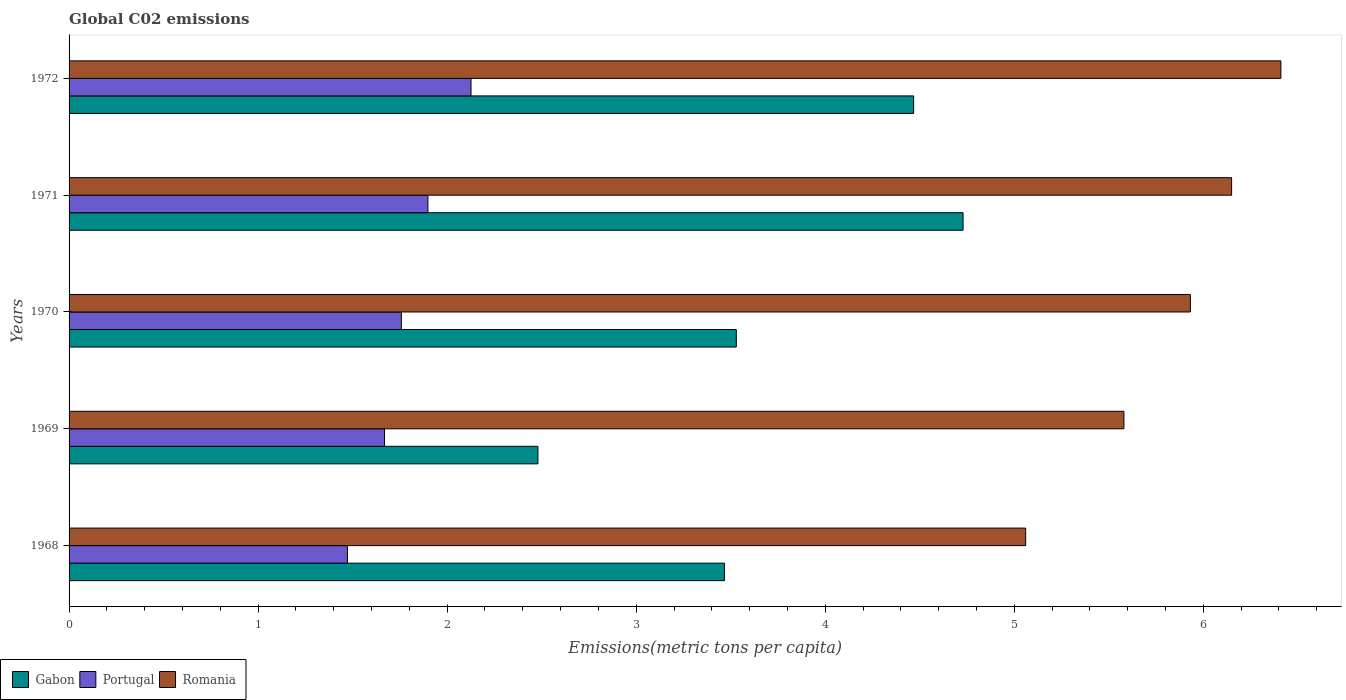How many groups of bars are there?
Provide a succinct answer. 5. How many bars are there on the 3rd tick from the top?
Provide a short and direct response. 3. What is the label of the 3rd group of bars from the top?
Ensure brevity in your answer.  1970. What is the amount of CO2 emitted in in Gabon in 1970?
Give a very brief answer. 3.53. Across all years, what is the maximum amount of CO2 emitted in in Romania?
Your response must be concise. 6.41. Across all years, what is the minimum amount of CO2 emitted in in Gabon?
Provide a short and direct response. 2.48. In which year was the amount of CO2 emitted in in Portugal minimum?
Offer a terse response. 1968. What is the total amount of CO2 emitted in in Romania in the graph?
Your answer should be very brief. 29.13. What is the difference between the amount of CO2 emitted in in Romania in 1969 and that in 1971?
Offer a very short reply. -0.57. What is the difference between the amount of CO2 emitted in in Portugal in 1969 and the amount of CO2 emitted in in Romania in 1972?
Make the answer very short. -4.74. What is the average amount of CO2 emitted in in Romania per year?
Your answer should be compact. 5.83. In the year 1972, what is the difference between the amount of CO2 emitted in in Portugal and amount of CO2 emitted in in Gabon?
Provide a succinct answer. -2.34. In how many years, is the amount of CO2 emitted in in Gabon greater than 1.4 metric tons per capita?
Ensure brevity in your answer.  5. What is the ratio of the amount of CO2 emitted in in Gabon in 1968 to that in 1969?
Your answer should be very brief. 1.4. What is the difference between the highest and the second highest amount of CO2 emitted in in Romania?
Provide a short and direct response. 0.26. What is the difference between the highest and the lowest amount of CO2 emitted in in Gabon?
Your response must be concise. 2.25. What does the 2nd bar from the top in 1969 represents?
Keep it short and to the point. Portugal. What does the 1st bar from the bottom in 1968 represents?
Offer a very short reply. Gabon. Is it the case that in every year, the sum of the amount of CO2 emitted in in Gabon and amount of CO2 emitted in in Portugal is greater than the amount of CO2 emitted in in Romania?
Keep it short and to the point. No. Are all the bars in the graph horizontal?
Offer a terse response. Yes. What is the difference between two consecutive major ticks on the X-axis?
Your response must be concise. 1. Does the graph contain grids?
Provide a succinct answer. No. Where does the legend appear in the graph?
Your answer should be very brief. Bottom left. How many legend labels are there?
Offer a very short reply. 3. What is the title of the graph?
Provide a short and direct response. Global C02 emissions. Does "Romania" appear as one of the legend labels in the graph?
Offer a very short reply. Yes. What is the label or title of the X-axis?
Provide a succinct answer. Emissions(metric tons per capita). What is the Emissions(metric tons per capita) of Gabon in 1968?
Your response must be concise. 3.47. What is the Emissions(metric tons per capita) in Portugal in 1968?
Offer a terse response. 1.47. What is the Emissions(metric tons per capita) of Romania in 1968?
Offer a terse response. 5.06. What is the Emissions(metric tons per capita) in Gabon in 1969?
Your answer should be compact. 2.48. What is the Emissions(metric tons per capita) in Portugal in 1969?
Offer a very short reply. 1.67. What is the Emissions(metric tons per capita) in Romania in 1969?
Give a very brief answer. 5.58. What is the Emissions(metric tons per capita) of Gabon in 1970?
Keep it short and to the point. 3.53. What is the Emissions(metric tons per capita) in Portugal in 1970?
Keep it short and to the point. 1.76. What is the Emissions(metric tons per capita) in Romania in 1970?
Keep it short and to the point. 5.93. What is the Emissions(metric tons per capita) of Gabon in 1971?
Your answer should be compact. 4.73. What is the Emissions(metric tons per capita) of Portugal in 1971?
Provide a short and direct response. 1.9. What is the Emissions(metric tons per capita) in Romania in 1971?
Your response must be concise. 6.15. What is the Emissions(metric tons per capita) of Gabon in 1972?
Your response must be concise. 4.47. What is the Emissions(metric tons per capita) of Portugal in 1972?
Offer a very short reply. 2.13. What is the Emissions(metric tons per capita) in Romania in 1972?
Provide a succinct answer. 6.41. Across all years, what is the maximum Emissions(metric tons per capita) of Gabon?
Your answer should be compact. 4.73. Across all years, what is the maximum Emissions(metric tons per capita) of Portugal?
Make the answer very short. 2.13. Across all years, what is the maximum Emissions(metric tons per capita) in Romania?
Provide a succinct answer. 6.41. Across all years, what is the minimum Emissions(metric tons per capita) in Gabon?
Keep it short and to the point. 2.48. Across all years, what is the minimum Emissions(metric tons per capita) in Portugal?
Ensure brevity in your answer.  1.47. Across all years, what is the minimum Emissions(metric tons per capita) in Romania?
Give a very brief answer. 5.06. What is the total Emissions(metric tons per capita) of Gabon in the graph?
Ensure brevity in your answer.  18.67. What is the total Emissions(metric tons per capita) of Portugal in the graph?
Provide a succinct answer. 8.92. What is the total Emissions(metric tons per capita) of Romania in the graph?
Provide a succinct answer. 29.13. What is the difference between the Emissions(metric tons per capita) of Portugal in 1968 and that in 1969?
Provide a short and direct response. -0.2. What is the difference between the Emissions(metric tons per capita) in Romania in 1968 and that in 1969?
Provide a succinct answer. -0.52. What is the difference between the Emissions(metric tons per capita) of Gabon in 1968 and that in 1970?
Offer a terse response. -0.06. What is the difference between the Emissions(metric tons per capita) in Portugal in 1968 and that in 1970?
Provide a succinct answer. -0.29. What is the difference between the Emissions(metric tons per capita) in Romania in 1968 and that in 1970?
Offer a very short reply. -0.87. What is the difference between the Emissions(metric tons per capita) in Gabon in 1968 and that in 1971?
Provide a succinct answer. -1.26. What is the difference between the Emissions(metric tons per capita) in Portugal in 1968 and that in 1971?
Ensure brevity in your answer.  -0.43. What is the difference between the Emissions(metric tons per capita) in Romania in 1968 and that in 1971?
Give a very brief answer. -1.09. What is the difference between the Emissions(metric tons per capita) of Gabon in 1968 and that in 1972?
Offer a terse response. -1. What is the difference between the Emissions(metric tons per capita) in Portugal in 1968 and that in 1972?
Offer a terse response. -0.65. What is the difference between the Emissions(metric tons per capita) of Romania in 1968 and that in 1972?
Your answer should be very brief. -1.35. What is the difference between the Emissions(metric tons per capita) of Gabon in 1969 and that in 1970?
Offer a terse response. -1.05. What is the difference between the Emissions(metric tons per capita) of Portugal in 1969 and that in 1970?
Your answer should be compact. -0.09. What is the difference between the Emissions(metric tons per capita) in Romania in 1969 and that in 1970?
Give a very brief answer. -0.35. What is the difference between the Emissions(metric tons per capita) of Gabon in 1969 and that in 1971?
Your answer should be very brief. -2.25. What is the difference between the Emissions(metric tons per capita) of Portugal in 1969 and that in 1971?
Provide a short and direct response. -0.23. What is the difference between the Emissions(metric tons per capita) of Romania in 1969 and that in 1971?
Keep it short and to the point. -0.57. What is the difference between the Emissions(metric tons per capita) in Gabon in 1969 and that in 1972?
Make the answer very short. -1.99. What is the difference between the Emissions(metric tons per capita) in Portugal in 1969 and that in 1972?
Your answer should be compact. -0.46. What is the difference between the Emissions(metric tons per capita) of Romania in 1969 and that in 1972?
Your response must be concise. -0.83. What is the difference between the Emissions(metric tons per capita) in Gabon in 1970 and that in 1971?
Make the answer very short. -1.2. What is the difference between the Emissions(metric tons per capita) in Portugal in 1970 and that in 1971?
Your response must be concise. -0.14. What is the difference between the Emissions(metric tons per capita) of Romania in 1970 and that in 1971?
Your response must be concise. -0.22. What is the difference between the Emissions(metric tons per capita) in Gabon in 1970 and that in 1972?
Give a very brief answer. -0.94. What is the difference between the Emissions(metric tons per capita) of Portugal in 1970 and that in 1972?
Offer a terse response. -0.37. What is the difference between the Emissions(metric tons per capita) in Romania in 1970 and that in 1972?
Keep it short and to the point. -0.48. What is the difference between the Emissions(metric tons per capita) of Gabon in 1971 and that in 1972?
Your answer should be compact. 0.26. What is the difference between the Emissions(metric tons per capita) of Portugal in 1971 and that in 1972?
Give a very brief answer. -0.23. What is the difference between the Emissions(metric tons per capita) in Romania in 1971 and that in 1972?
Keep it short and to the point. -0.26. What is the difference between the Emissions(metric tons per capita) in Gabon in 1968 and the Emissions(metric tons per capita) in Portugal in 1969?
Provide a short and direct response. 1.8. What is the difference between the Emissions(metric tons per capita) in Gabon in 1968 and the Emissions(metric tons per capita) in Romania in 1969?
Your answer should be very brief. -2.11. What is the difference between the Emissions(metric tons per capita) of Portugal in 1968 and the Emissions(metric tons per capita) of Romania in 1969?
Make the answer very short. -4.11. What is the difference between the Emissions(metric tons per capita) of Gabon in 1968 and the Emissions(metric tons per capita) of Portugal in 1970?
Keep it short and to the point. 1.71. What is the difference between the Emissions(metric tons per capita) in Gabon in 1968 and the Emissions(metric tons per capita) in Romania in 1970?
Offer a very short reply. -2.46. What is the difference between the Emissions(metric tons per capita) of Portugal in 1968 and the Emissions(metric tons per capita) of Romania in 1970?
Provide a short and direct response. -4.46. What is the difference between the Emissions(metric tons per capita) in Gabon in 1968 and the Emissions(metric tons per capita) in Portugal in 1971?
Your response must be concise. 1.57. What is the difference between the Emissions(metric tons per capita) of Gabon in 1968 and the Emissions(metric tons per capita) of Romania in 1971?
Make the answer very short. -2.68. What is the difference between the Emissions(metric tons per capita) in Portugal in 1968 and the Emissions(metric tons per capita) in Romania in 1971?
Make the answer very short. -4.68. What is the difference between the Emissions(metric tons per capita) of Gabon in 1968 and the Emissions(metric tons per capita) of Portugal in 1972?
Your answer should be compact. 1.34. What is the difference between the Emissions(metric tons per capita) of Gabon in 1968 and the Emissions(metric tons per capita) of Romania in 1972?
Offer a very short reply. -2.94. What is the difference between the Emissions(metric tons per capita) of Portugal in 1968 and the Emissions(metric tons per capita) of Romania in 1972?
Give a very brief answer. -4.94. What is the difference between the Emissions(metric tons per capita) in Gabon in 1969 and the Emissions(metric tons per capita) in Portugal in 1970?
Ensure brevity in your answer.  0.72. What is the difference between the Emissions(metric tons per capita) in Gabon in 1969 and the Emissions(metric tons per capita) in Romania in 1970?
Offer a terse response. -3.45. What is the difference between the Emissions(metric tons per capita) in Portugal in 1969 and the Emissions(metric tons per capita) in Romania in 1970?
Provide a succinct answer. -4.26. What is the difference between the Emissions(metric tons per capita) of Gabon in 1969 and the Emissions(metric tons per capita) of Portugal in 1971?
Offer a very short reply. 0.58. What is the difference between the Emissions(metric tons per capita) in Gabon in 1969 and the Emissions(metric tons per capita) in Romania in 1971?
Provide a succinct answer. -3.67. What is the difference between the Emissions(metric tons per capita) in Portugal in 1969 and the Emissions(metric tons per capita) in Romania in 1971?
Your response must be concise. -4.48. What is the difference between the Emissions(metric tons per capita) of Gabon in 1969 and the Emissions(metric tons per capita) of Portugal in 1972?
Give a very brief answer. 0.35. What is the difference between the Emissions(metric tons per capita) in Gabon in 1969 and the Emissions(metric tons per capita) in Romania in 1972?
Make the answer very short. -3.93. What is the difference between the Emissions(metric tons per capita) of Portugal in 1969 and the Emissions(metric tons per capita) of Romania in 1972?
Make the answer very short. -4.74. What is the difference between the Emissions(metric tons per capita) in Gabon in 1970 and the Emissions(metric tons per capita) in Portugal in 1971?
Keep it short and to the point. 1.63. What is the difference between the Emissions(metric tons per capita) of Gabon in 1970 and the Emissions(metric tons per capita) of Romania in 1971?
Your answer should be very brief. -2.62. What is the difference between the Emissions(metric tons per capita) of Portugal in 1970 and the Emissions(metric tons per capita) of Romania in 1971?
Ensure brevity in your answer.  -4.39. What is the difference between the Emissions(metric tons per capita) in Gabon in 1970 and the Emissions(metric tons per capita) in Portugal in 1972?
Offer a terse response. 1.4. What is the difference between the Emissions(metric tons per capita) of Gabon in 1970 and the Emissions(metric tons per capita) of Romania in 1972?
Your answer should be very brief. -2.88. What is the difference between the Emissions(metric tons per capita) in Portugal in 1970 and the Emissions(metric tons per capita) in Romania in 1972?
Ensure brevity in your answer.  -4.65. What is the difference between the Emissions(metric tons per capita) of Gabon in 1971 and the Emissions(metric tons per capita) of Portugal in 1972?
Offer a terse response. 2.6. What is the difference between the Emissions(metric tons per capita) of Gabon in 1971 and the Emissions(metric tons per capita) of Romania in 1972?
Offer a terse response. -1.68. What is the difference between the Emissions(metric tons per capita) in Portugal in 1971 and the Emissions(metric tons per capita) in Romania in 1972?
Your answer should be compact. -4.51. What is the average Emissions(metric tons per capita) in Gabon per year?
Give a very brief answer. 3.73. What is the average Emissions(metric tons per capita) in Portugal per year?
Your answer should be very brief. 1.78. What is the average Emissions(metric tons per capita) in Romania per year?
Give a very brief answer. 5.83. In the year 1968, what is the difference between the Emissions(metric tons per capita) in Gabon and Emissions(metric tons per capita) in Portugal?
Offer a very short reply. 1.99. In the year 1968, what is the difference between the Emissions(metric tons per capita) in Gabon and Emissions(metric tons per capita) in Romania?
Your answer should be compact. -1.59. In the year 1968, what is the difference between the Emissions(metric tons per capita) in Portugal and Emissions(metric tons per capita) in Romania?
Your response must be concise. -3.59. In the year 1969, what is the difference between the Emissions(metric tons per capita) of Gabon and Emissions(metric tons per capita) of Portugal?
Offer a terse response. 0.81. In the year 1969, what is the difference between the Emissions(metric tons per capita) in Gabon and Emissions(metric tons per capita) in Romania?
Give a very brief answer. -3.1. In the year 1969, what is the difference between the Emissions(metric tons per capita) in Portugal and Emissions(metric tons per capita) in Romania?
Your response must be concise. -3.91. In the year 1970, what is the difference between the Emissions(metric tons per capita) in Gabon and Emissions(metric tons per capita) in Portugal?
Provide a succinct answer. 1.77. In the year 1970, what is the difference between the Emissions(metric tons per capita) in Gabon and Emissions(metric tons per capita) in Romania?
Give a very brief answer. -2.4. In the year 1970, what is the difference between the Emissions(metric tons per capita) in Portugal and Emissions(metric tons per capita) in Romania?
Offer a terse response. -4.17. In the year 1971, what is the difference between the Emissions(metric tons per capita) in Gabon and Emissions(metric tons per capita) in Portugal?
Offer a terse response. 2.83. In the year 1971, what is the difference between the Emissions(metric tons per capita) of Gabon and Emissions(metric tons per capita) of Romania?
Your answer should be compact. -1.42. In the year 1971, what is the difference between the Emissions(metric tons per capita) of Portugal and Emissions(metric tons per capita) of Romania?
Provide a short and direct response. -4.25. In the year 1972, what is the difference between the Emissions(metric tons per capita) of Gabon and Emissions(metric tons per capita) of Portugal?
Your answer should be very brief. 2.34. In the year 1972, what is the difference between the Emissions(metric tons per capita) in Gabon and Emissions(metric tons per capita) in Romania?
Your answer should be compact. -1.94. In the year 1972, what is the difference between the Emissions(metric tons per capita) in Portugal and Emissions(metric tons per capita) in Romania?
Provide a short and direct response. -4.28. What is the ratio of the Emissions(metric tons per capita) of Gabon in 1968 to that in 1969?
Make the answer very short. 1.4. What is the ratio of the Emissions(metric tons per capita) of Portugal in 1968 to that in 1969?
Provide a succinct answer. 0.88. What is the ratio of the Emissions(metric tons per capita) of Romania in 1968 to that in 1969?
Your answer should be very brief. 0.91. What is the ratio of the Emissions(metric tons per capita) of Gabon in 1968 to that in 1970?
Offer a terse response. 0.98. What is the ratio of the Emissions(metric tons per capita) in Portugal in 1968 to that in 1970?
Your response must be concise. 0.84. What is the ratio of the Emissions(metric tons per capita) in Romania in 1968 to that in 1970?
Your answer should be compact. 0.85. What is the ratio of the Emissions(metric tons per capita) in Gabon in 1968 to that in 1971?
Offer a very short reply. 0.73. What is the ratio of the Emissions(metric tons per capita) in Portugal in 1968 to that in 1971?
Ensure brevity in your answer.  0.78. What is the ratio of the Emissions(metric tons per capita) of Romania in 1968 to that in 1971?
Ensure brevity in your answer.  0.82. What is the ratio of the Emissions(metric tons per capita) in Gabon in 1968 to that in 1972?
Keep it short and to the point. 0.78. What is the ratio of the Emissions(metric tons per capita) of Portugal in 1968 to that in 1972?
Make the answer very short. 0.69. What is the ratio of the Emissions(metric tons per capita) in Romania in 1968 to that in 1972?
Make the answer very short. 0.79. What is the ratio of the Emissions(metric tons per capita) in Gabon in 1969 to that in 1970?
Give a very brief answer. 0.7. What is the ratio of the Emissions(metric tons per capita) of Portugal in 1969 to that in 1970?
Provide a succinct answer. 0.95. What is the ratio of the Emissions(metric tons per capita) of Romania in 1969 to that in 1970?
Offer a very short reply. 0.94. What is the ratio of the Emissions(metric tons per capita) of Gabon in 1969 to that in 1971?
Your response must be concise. 0.52. What is the ratio of the Emissions(metric tons per capita) of Portugal in 1969 to that in 1971?
Ensure brevity in your answer.  0.88. What is the ratio of the Emissions(metric tons per capita) in Romania in 1969 to that in 1971?
Make the answer very short. 0.91. What is the ratio of the Emissions(metric tons per capita) in Gabon in 1969 to that in 1972?
Provide a succinct answer. 0.56. What is the ratio of the Emissions(metric tons per capita) of Portugal in 1969 to that in 1972?
Keep it short and to the point. 0.78. What is the ratio of the Emissions(metric tons per capita) in Romania in 1969 to that in 1972?
Provide a succinct answer. 0.87. What is the ratio of the Emissions(metric tons per capita) of Gabon in 1970 to that in 1971?
Offer a terse response. 0.75. What is the ratio of the Emissions(metric tons per capita) of Portugal in 1970 to that in 1971?
Your response must be concise. 0.93. What is the ratio of the Emissions(metric tons per capita) in Romania in 1970 to that in 1971?
Ensure brevity in your answer.  0.96. What is the ratio of the Emissions(metric tons per capita) of Gabon in 1970 to that in 1972?
Offer a very short reply. 0.79. What is the ratio of the Emissions(metric tons per capita) of Portugal in 1970 to that in 1972?
Give a very brief answer. 0.83. What is the ratio of the Emissions(metric tons per capita) in Romania in 1970 to that in 1972?
Ensure brevity in your answer.  0.93. What is the ratio of the Emissions(metric tons per capita) of Gabon in 1971 to that in 1972?
Your response must be concise. 1.06. What is the ratio of the Emissions(metric tons per capita) of Portugal in 1971 to that in 1972?
Offer a terse response. 0.89. What is the ratio of the Emissions(metric tons per capita) of Romania in 1971 to that in 1972?
Make the answer very short. 0.96. What is the difference between the highest and the second highest Emissions(metric tons per capita) in Gabon?
Your answer should be compact. 0.26. What is the difference between the highest and the second highest Emissions(metric tons per capita) in Portugal?
Offer a terse response. 0.23. What is the difference between the highest and the second highest Emissions(metric tons per capita) in Romania?
Give a very brief answer. 0.26. What is the difference between the highest and the lowest Emissions(metric tons per capita) of Gabon?
Offer a very short reply. 2.25. What is the difference between the highest and the lowest Emissions(metric tons per capita) of Portugal?
Your answer should be very brief. 0.65. What is the difference between the highest and the lowest Emissions(metric tons per capita) in Romania?
Keep it short and to the point. 1.35. 